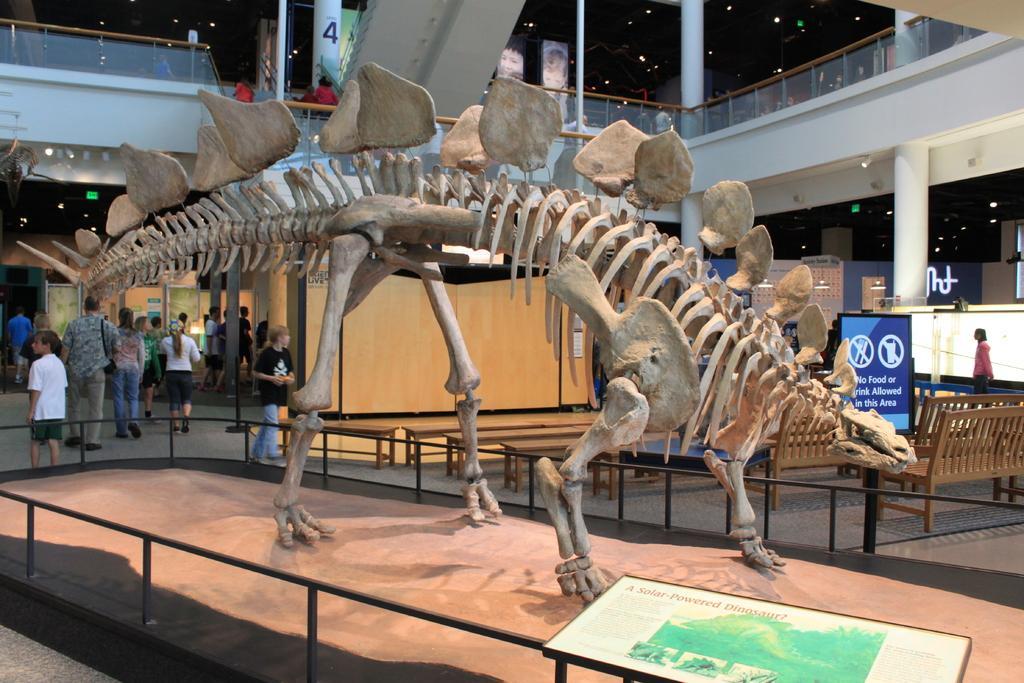How would you summarize this image in a sentence or two? In this picture we can see a skeleton of an animal on the table, there are few people, pillars, chairs, benches, lights, exit boards and posters with some text. 